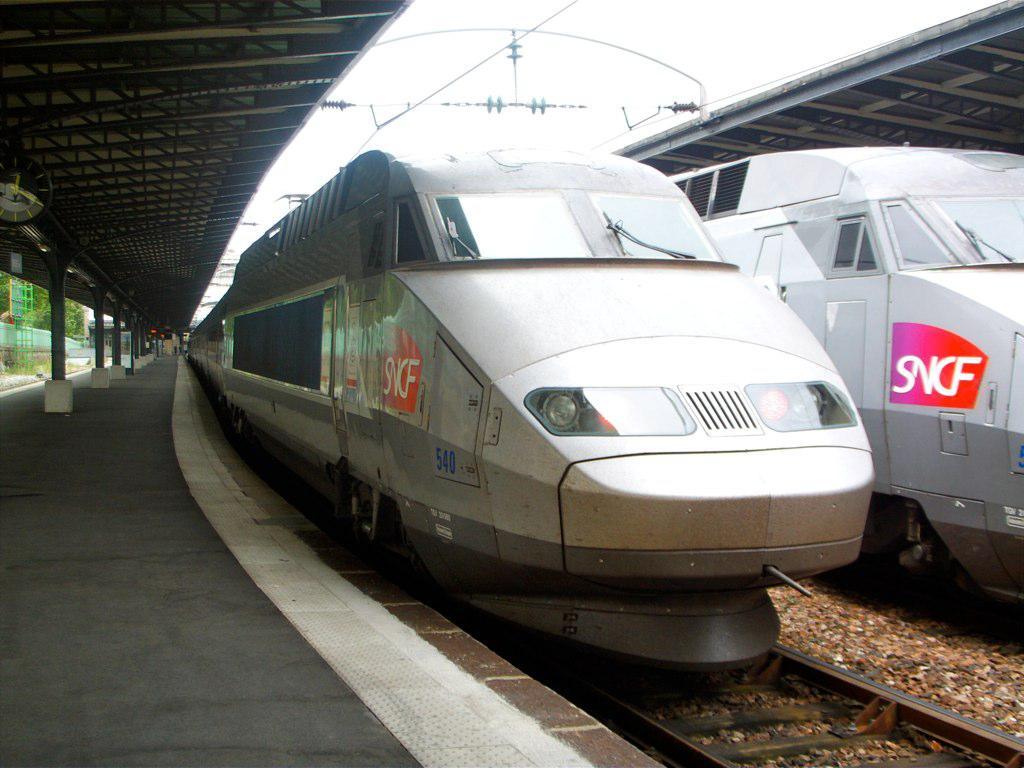What is the train number?
Keep it short and to the point. 540. 